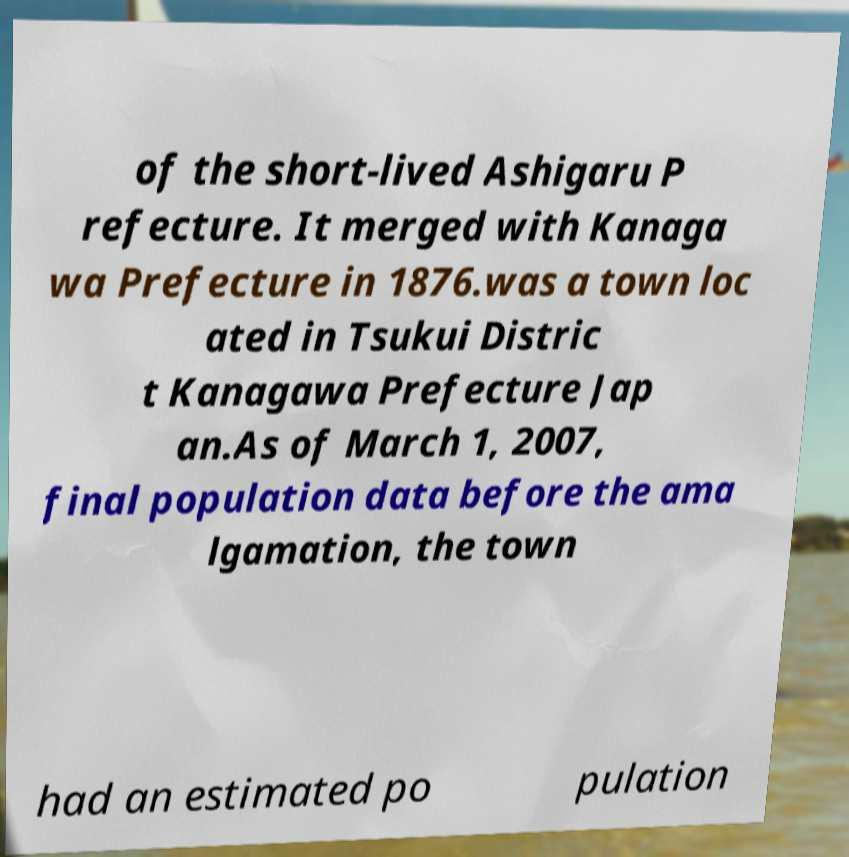Can you accurately transcribe the text from the provided image for me? of the short-lived Ashigaru P refecture. It merged with Kanaga wa Prefecture in 1876.was a town loc ated in Tsukui Distric t Kanagawa Prefecture Jap an.As of March 1, 2007, final population data before the ama lgamation, the town had an estimated po pulation 